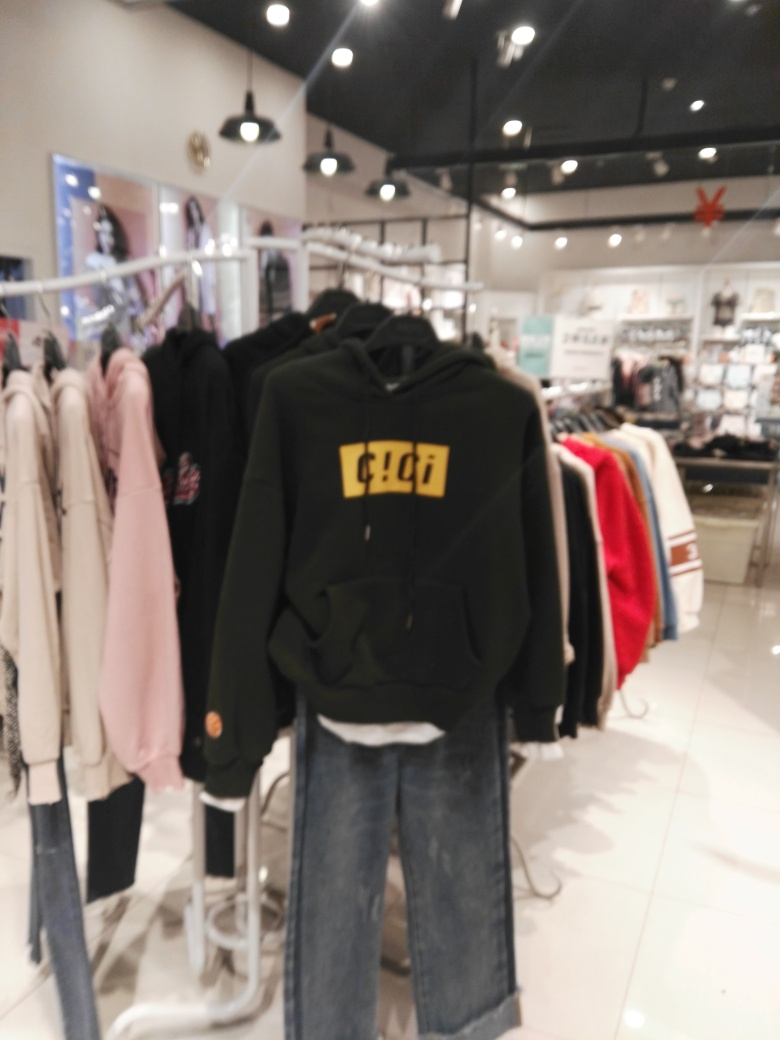What is the overall quality of this image?
A. Low
B. High
C. Average The overall quality of this image is low due to the apparent lack of focus, excessive blurriness and poor lighting conditions that inhibit the viewer from seeing the details clearly. Such characteristics suggest that the image may have been taken hastily or with a low-resolution camera under suboptimal lighting conditions. 